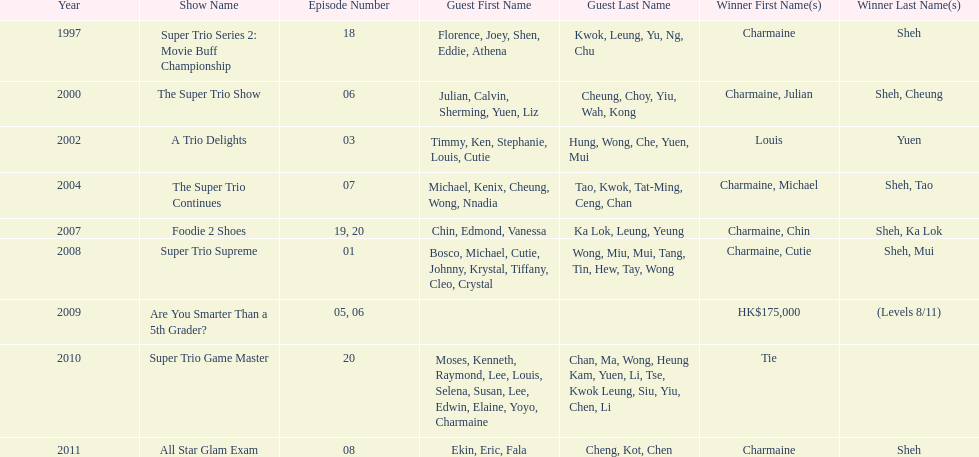How long has it been since chermaine sheh first appeared on a variety show? 17 years. 